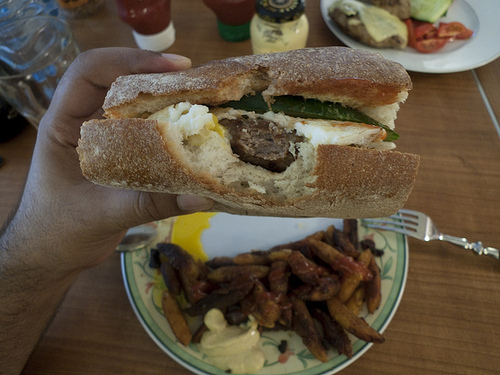<image>
Is the tomato behind the sandwich? Yes. From this viewpoint, the tomato is positioned behind the sandwich, with the sandwich partially or fully occluding the tomato. 